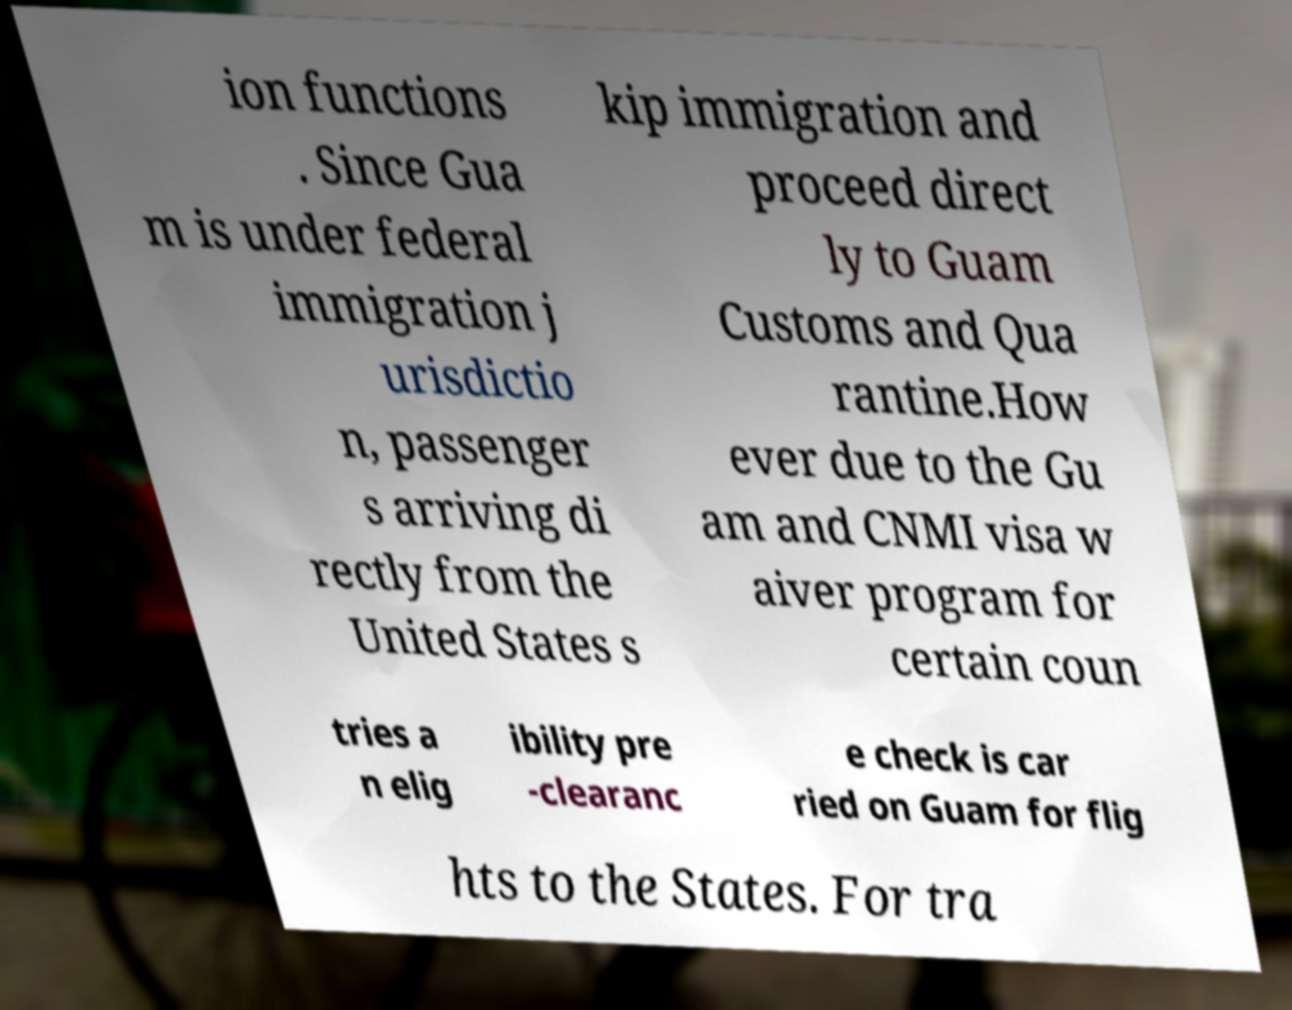There's text embedded in this image that I need extracted. Can you transcribe it verbatim? ion functions . Since Gua m is under federal immigration j urisdictio n, passenger s arriving di rectly from the United States s kip immigration and proceed direct ly to Guam Customs and Qua rantine.How ever due to the Gu am and CNMI visa w aiver program for certain coun tries a n elig ibility pre -clearanc e check is car ried on Guam for flig hts to the States. For tra 